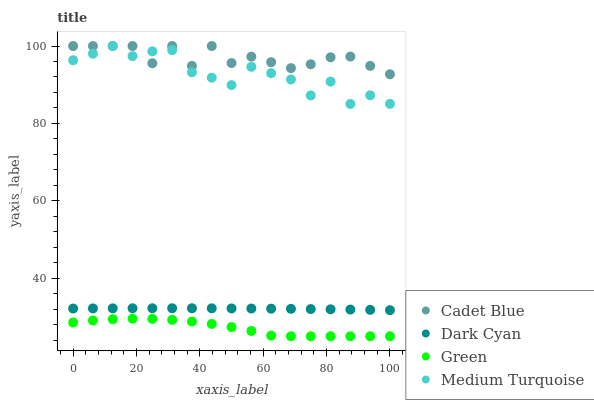Does Green have the minimum area under the curve?
Answer yes or no. Yes. Does Cadet Blue have the maximum area under the curve?
Answer yes or no. Yes. Does Cadet Blue have the minimum area under the curve?
Answer yes or no. No. Does Green have the maximum area under the curve?
Answer yes or no. No. Is Dark Cyan the smoothest?
Answer yes or no. Yes. Is Medium Turquoise the roughest?
Answer yes or no. Yes. Is Cadet Blue the smoothest?
Answer yes or no. No. Is Cadet Blue the roughest?
Answer yes or no. No. Does Green have the lowest value?
Answer yes or no. Yes. Does Cadet Blue have the lowest value?
Answer yes or no. No. Does Medium Turquoise have the highest value?
Answer yes or no. Yes. Does Green have the highest value?
Answer yes or no. No. Is Dark Cyan less than Medium Turquoise?
Answer yes or no. Yes. Is Dark Cyan greater than Green?
Answer yes or no. Yes. Does Medium Turquoise intersect Cadet Blue?
Answer yes or no. Yes. Is Medium Turquoise less than Cadet Blue?
Answer yes or no. No. Is Medium Turquoise greater than Cadet Blue?
Answer yes or no. No. Does Dark Cyan intersect Medium Turquoise?
Answer yes or no. No. 